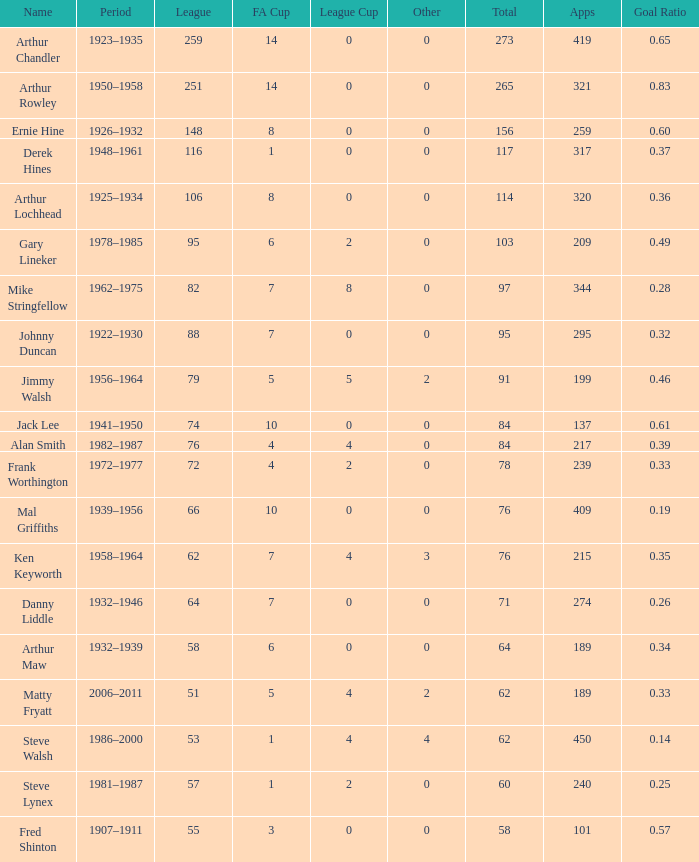What's the lowest Total thats got an FA Cup larger than 10, Name of Arthur Chandler, and a League Cup thats larger than 0? None. 